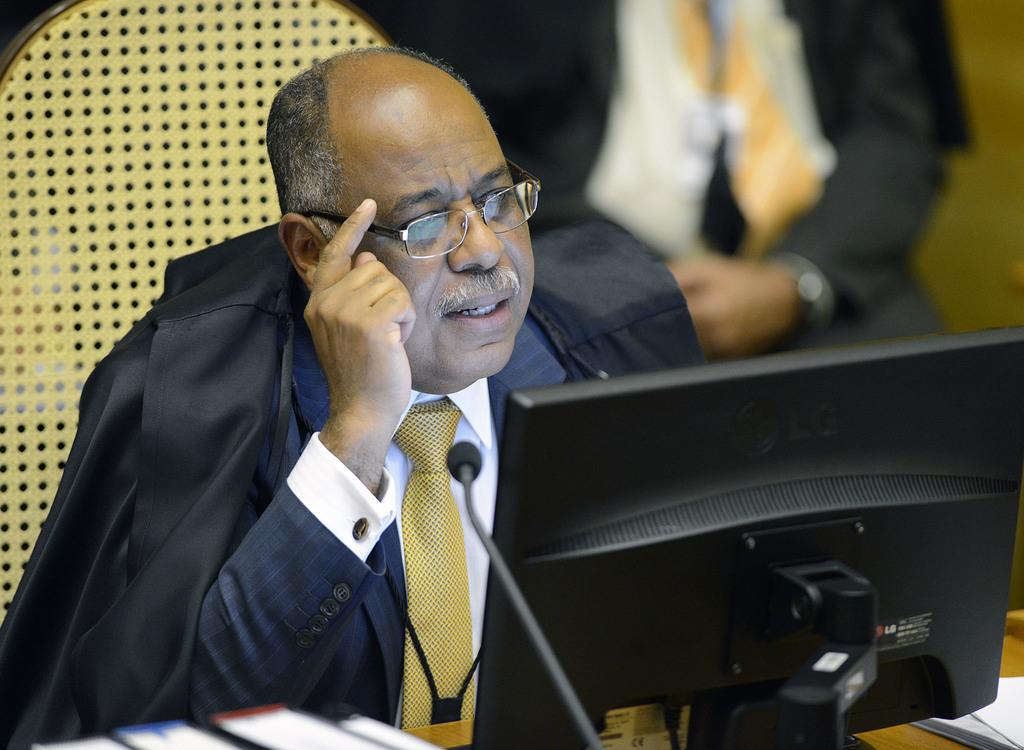What is the main subject of the image? There is a person sitting in the image. What is the person sitting in front of? The person is sitting in front of a computer. Can you describe the setting of the image? There is another person sitting in the backdrop of the image. How many frogs can be seen jumping in the image? There are no frogs present in the image. What action is the person in the image taking with the push of a button? There is no mention of a button or any action being taken in the image. 